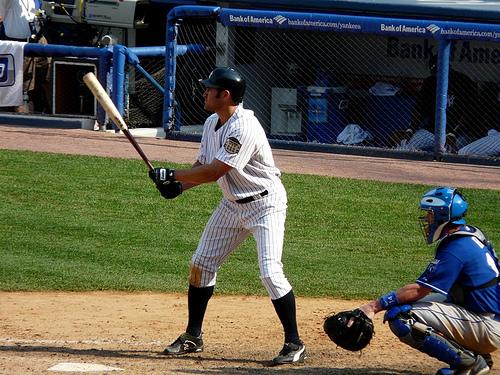What base is he standing in?
Quick response, please. Home. What color helmet is the catcher wearing?
Concise answer only. Blue. What is the man holding in his right hand?
Keep it brief. Bat. Is the sport baseball?
Quick response, please. Yes. Is there a striped uniform?
Give a very brief answer. Yes. Is this t ball?
Give a very brief answer. No. 